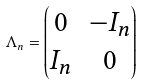Convert formula to latex. <formula><loc_0><loc_0><loc_500><loc_500>\Lambda _ { n } = \begin{pmatrix} 0 & - I _ { n } \\ I _ { n } & 0 \\ \end{pmatrix}</formula> 